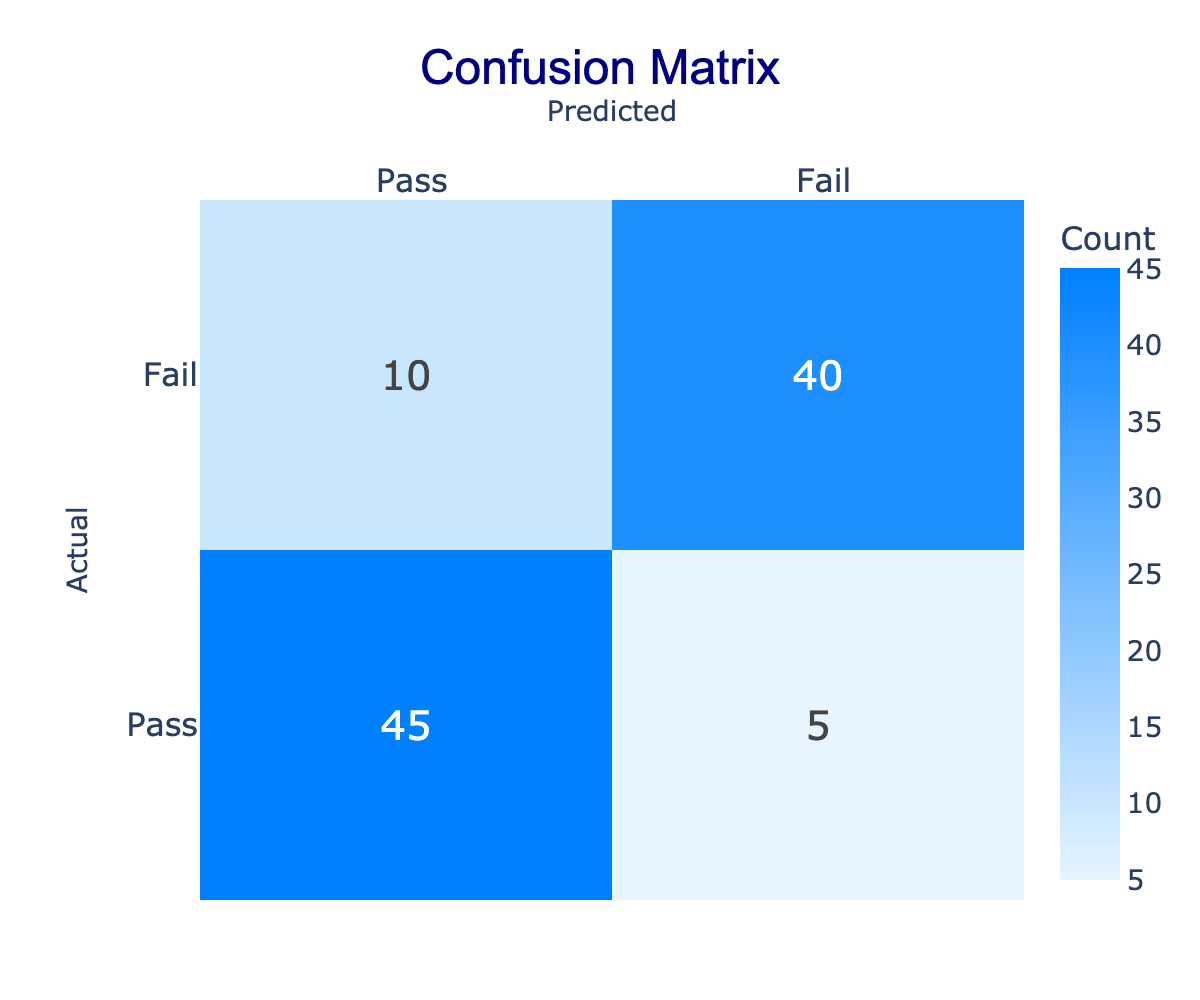What is the total number of students who passed the mathematics course? The confusion matrix shows that 45 students passed and 10 students failed (predicted to fail). Therefore, the total number of students who passed is simply the count of those who passed, which is 45.
Answer: 45 What is the total number of students who failed the mathematics course according to the matrix? To determine how many students failed, we look at the confusion matrix. It shows that 5 students who actually passed were predicted to fail and 40 students actually failed. Therefore, the total number of students who failed is 5 + 40 = 45.
Answer: 45 What is the number of students who were correctly predicted to pass? According to the matrix, the number of students who were correctly predicted to pass is noted in the cell corresponding to "Actual Pass" and "Predicted Pass," which is 45.
Answer: 45 What is the number of students who were incorrectly predicted to fail? The confusion matrix indicates that the number of students who actually passed but were predicted to fail is 5. Thus, this is the answer to the question.
Answer: 5 Are there more students who correctly passed than those who correctly failed? The confusion matrix shows 45 students were correctly predicted to pass, while 40 students were correctly predicted to fail. Since 45 is greater than 40, the answer is yes.
Answer: Yes What is the difference between the number of correct predictions for pass and fail? The number of correct predictions for pass is 45, and for fail is 40. To find the difference, we subtract: 45 - 40 = 5. Therefore, the difference is 5.
Answer: 5 What percentage of students who actually passed were correctly predicted to pass? In the matrix, there are 45 students who passed correctly predicted (true positives) and a total of 50 students who actually passed (45 who passed and 5 who were incorrectly predicted to fail). To find the percentage, we calculate (45/50) * 100 = 90%.
Answer: 90% If 10 students failed but were predicted to pass, what percentage of total predictions is this? The matrix shows that 10 students failed but were predicted to pass. The total number of predictions made (50) includes both predicted passes (45) and predicted fails (5). Therefore, the percentage is (10/50) * 100 = 20%.
Answer: 20% How many students showed discrepancies in predictions between actual and expected outcomes? Discrepancies occur with mispredictions. The total discrepancies consist of students incorrectly predicted to pass (10) and those incorrectly predicted to fail (5). Adding these together gives 10 + 5 = 15 discrepancies.
Answer: 15 